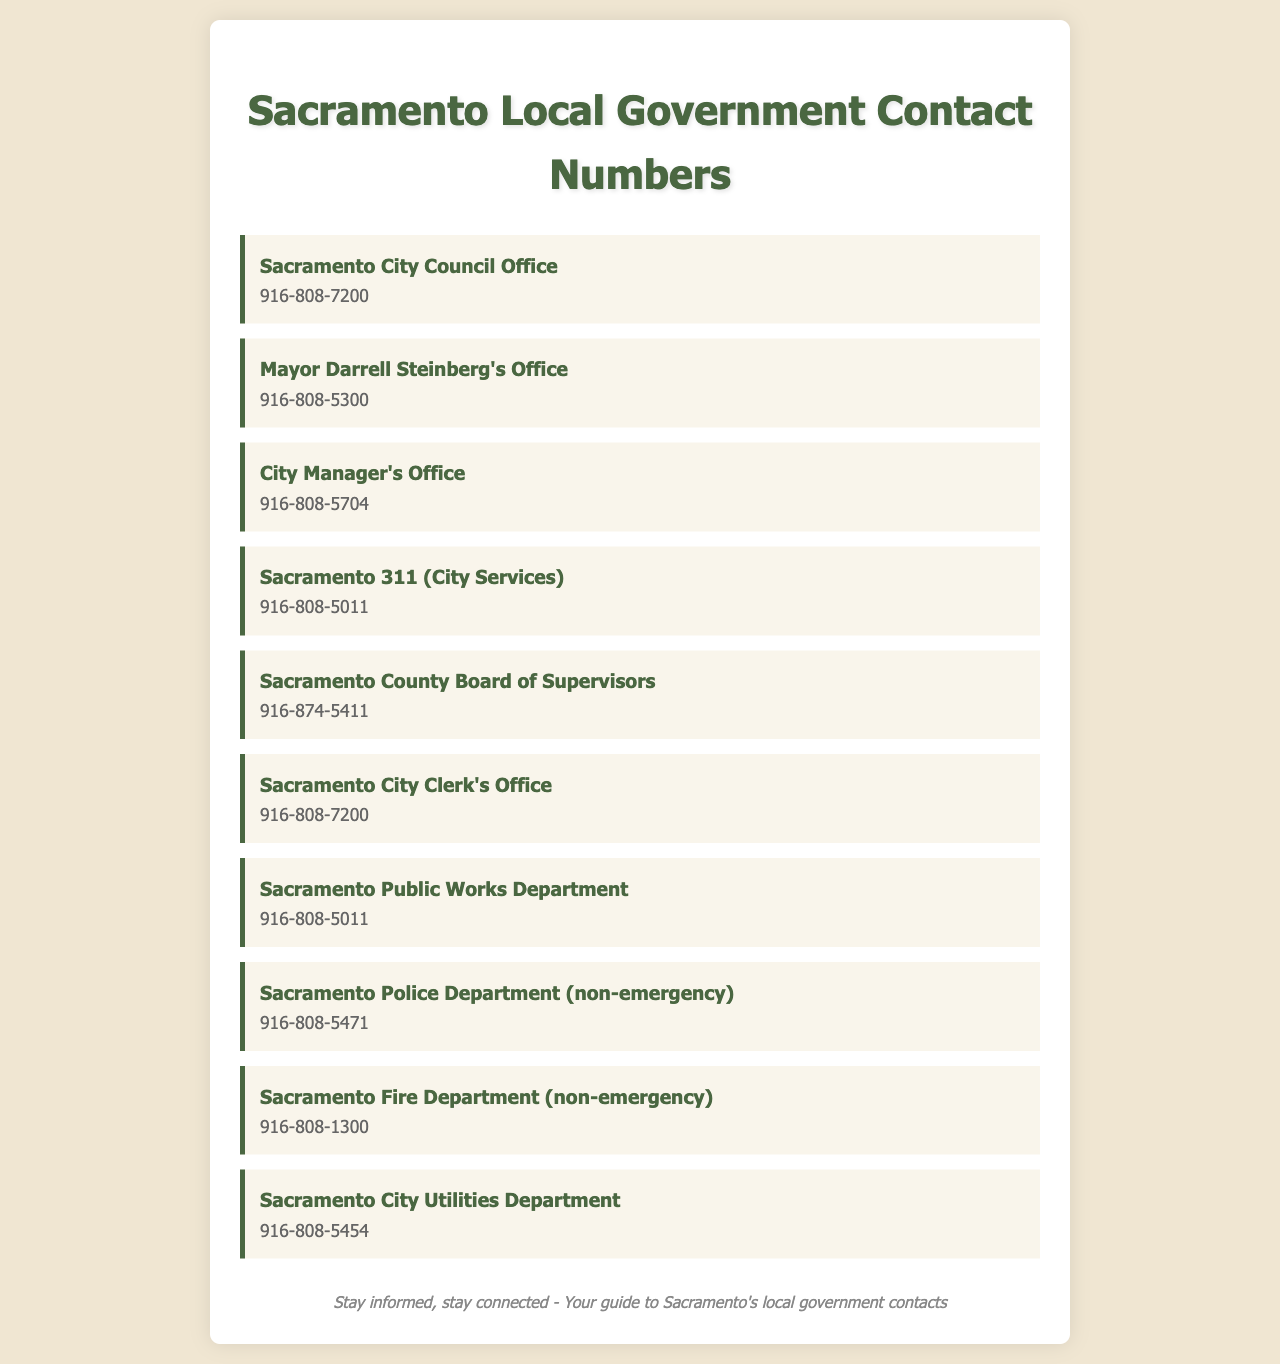What is the contact number for the Sacramento City Council Office? The contact number can be found under the Sacramento City Council Office listing in the document.
Answer: 916-808-7200 Who is the Mayor of Sacramento? The document provides the name of the Mayor listed in the Mayor's Office section.
Answer: Darrell Steinberg What department does the contact number 916-808-5011 represent? The number appears under two separate entries in the document: Sacramento 311 and Sacramento Public Works Department.
Answer: Sacramento 311 (City Services) How many different contact numbers are listed for the public works related services? There are two entries for services provided by public works in the document, each has a contact number.
Answer: 2 What is the non-emergency contact number for the Sacramento Police Department? The document specifies the non-emergency contact number for law enforcement services.
Answer: 916-808-5471 Which office shares the same contact number as the Sacramento City Council Office? The Sacramento City Clerk's Office shares the same number as listed in the document.
Answer: Sacramento City Clerk's Office What is the title of the office that has the contact number 916-808-5704? The contact number is associated with a specific office listed in the document.
Answer: City Manager's Office What can you contact if you have a utility inquiry? The document indicates which department to reach out to for utility inquiries.
Answer: Sacramento City Utilities Department 